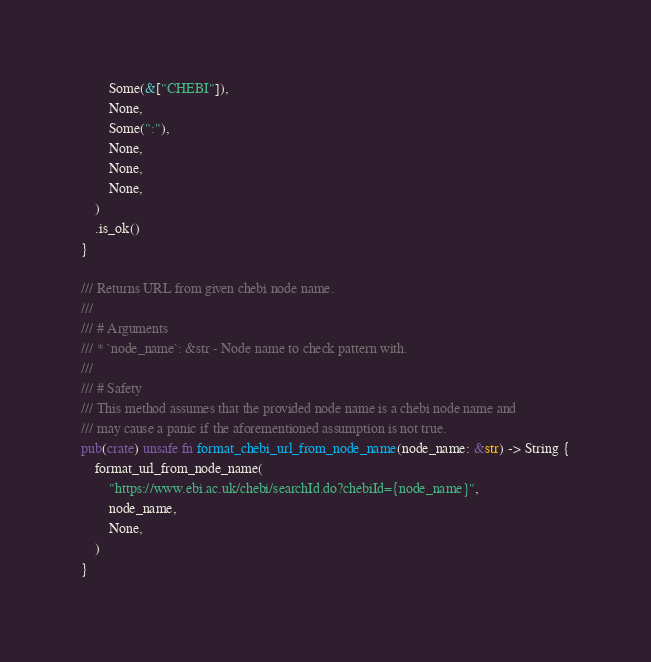<code> <loc_0><loc_0><loc_500><loc_500><_Rust_>        Some(&["CHEBI"]),
        None,
        Some(":"),
        None,
        None,
        None,
    )
    .is_ok()
}

/// Returns URL from given chebi node name.
///
/// # Arguments
/// * `node_name`: &str - Node name to check pattern with.
///
/// # Safety
/// This method assumes that the provided node name is a chebi node name and
/// may cause a panic if the aforementioned assumption is not true.
pub(crate) unsafe fn format_chebi_url_from_node_name(node_name: &str) -> String {
    format_url_from_node_name(
        "https://www.ebi.ac.uk/chebi/searchId.do?chebiId={node_name}",
        node_name,
        None,
    )
}
</code> 